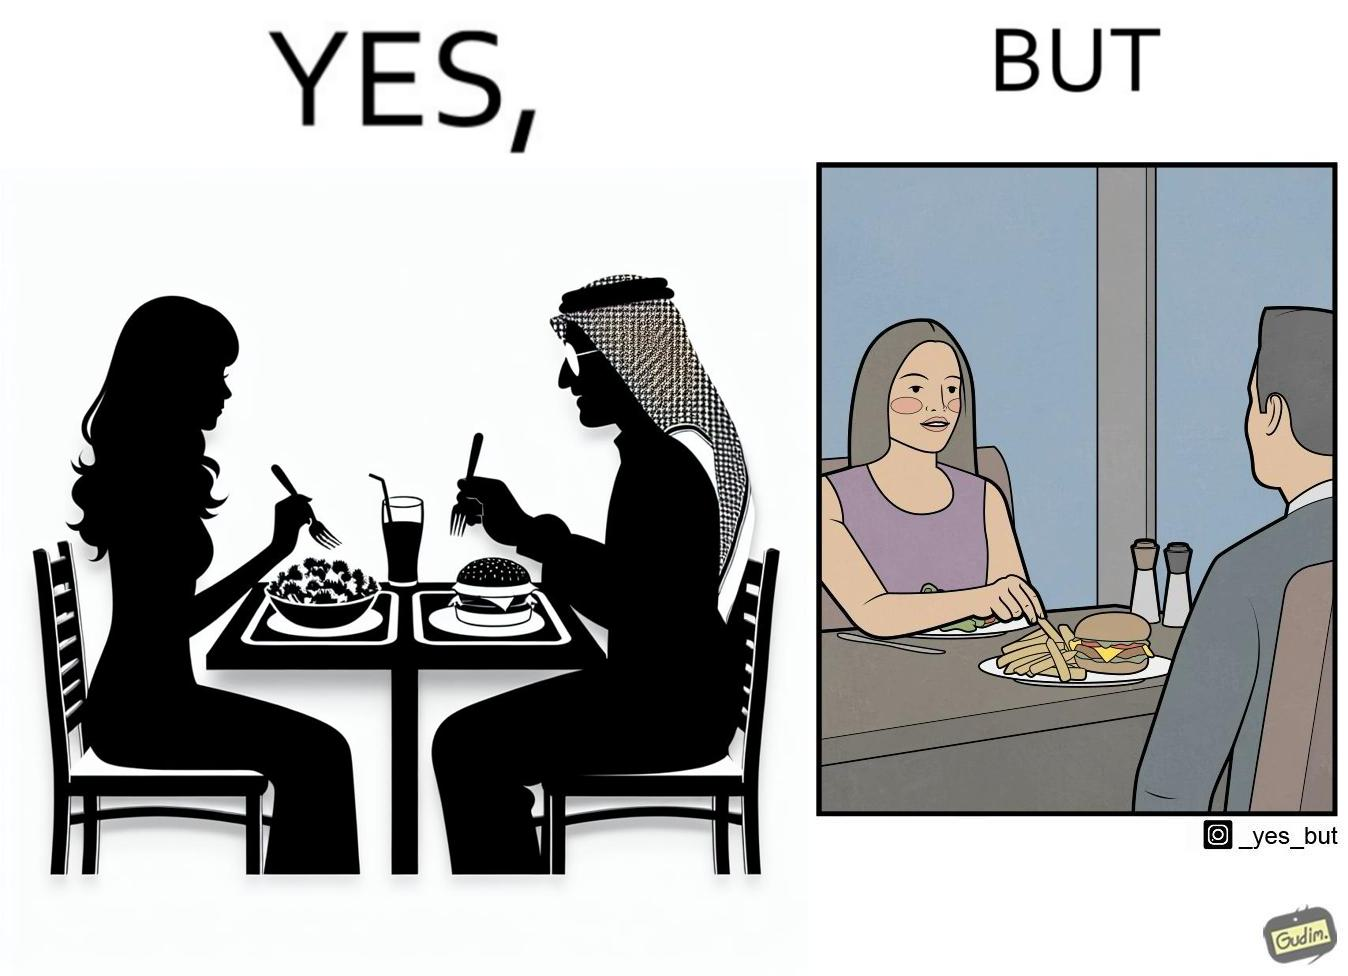Why is this image considered satirical? The image is ironic because in the first image it is shown that the woman has got salad for her but she is having french fries from the man's plate which displays that the girl is trying to show herself as health conscious by having a plate of salad for her but she wants to have to have fast food but rather than having them for herself she is taking some from other's plate 